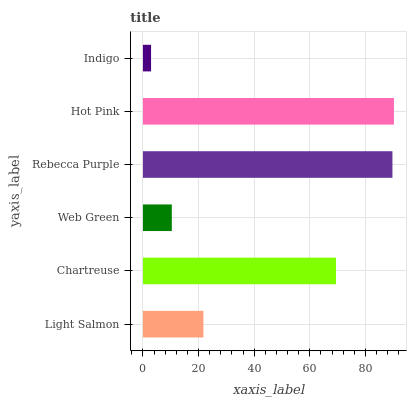Is Indigo the minimum?
Answer yes or no. Yes. Is Hot Pink the maximum?
Answer yes or no. Yes. Is Chartreuse the minimum?
Answer yes or no. No. Is Chartreuse the maximum?
Answer yes or no. No. Is Chartreuse greater than Light Salmon?
Answer yes or no. Yes. Is Light Salmon less than Chartreuse?
Answer yes or no. Yes. Is Light Salmon greater than Chartreuse?
Answer yes or no. No. Is Chartreuse less than Light Salmon?
Answer yes or no. No. Is Chartreuse the high median?
Answer yes or no. Yes. Is Light Salmon the low median?
Answer yes or no. Yes. Is Rebecca Purple the high median?
Answer yes or no. No. Is Chartreuse the low median?
Answer yes or no. No. 